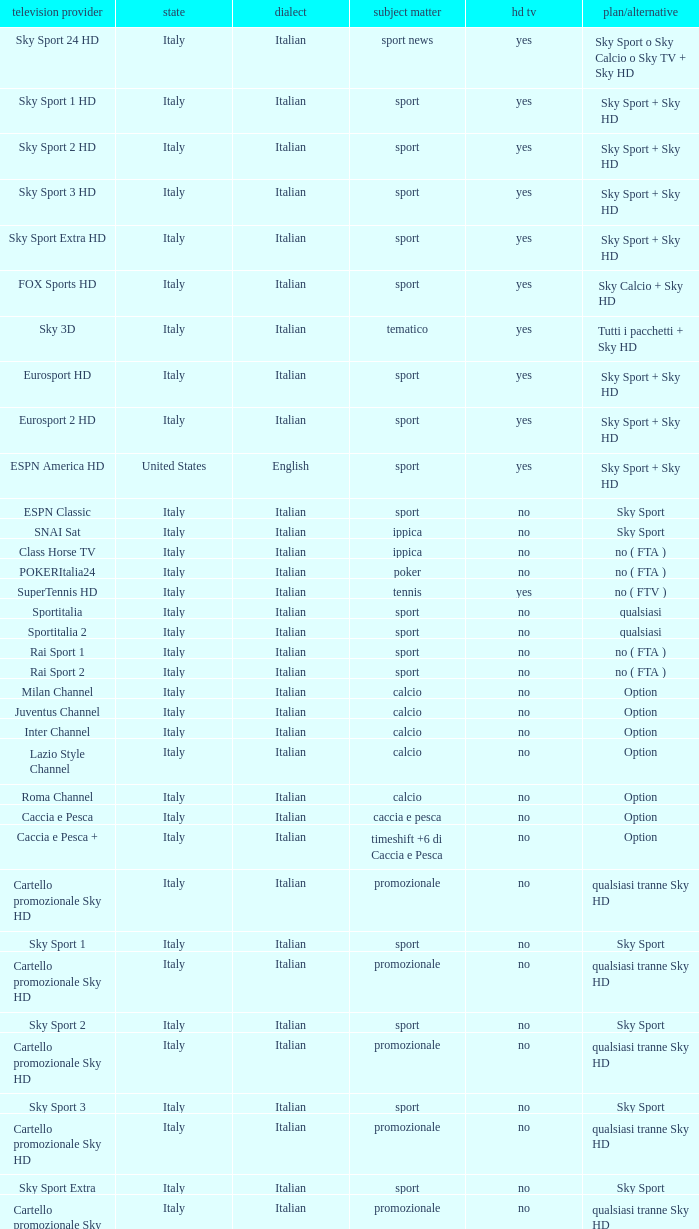What is Package/Option, when Content is Tennis? No ( ftv ). 